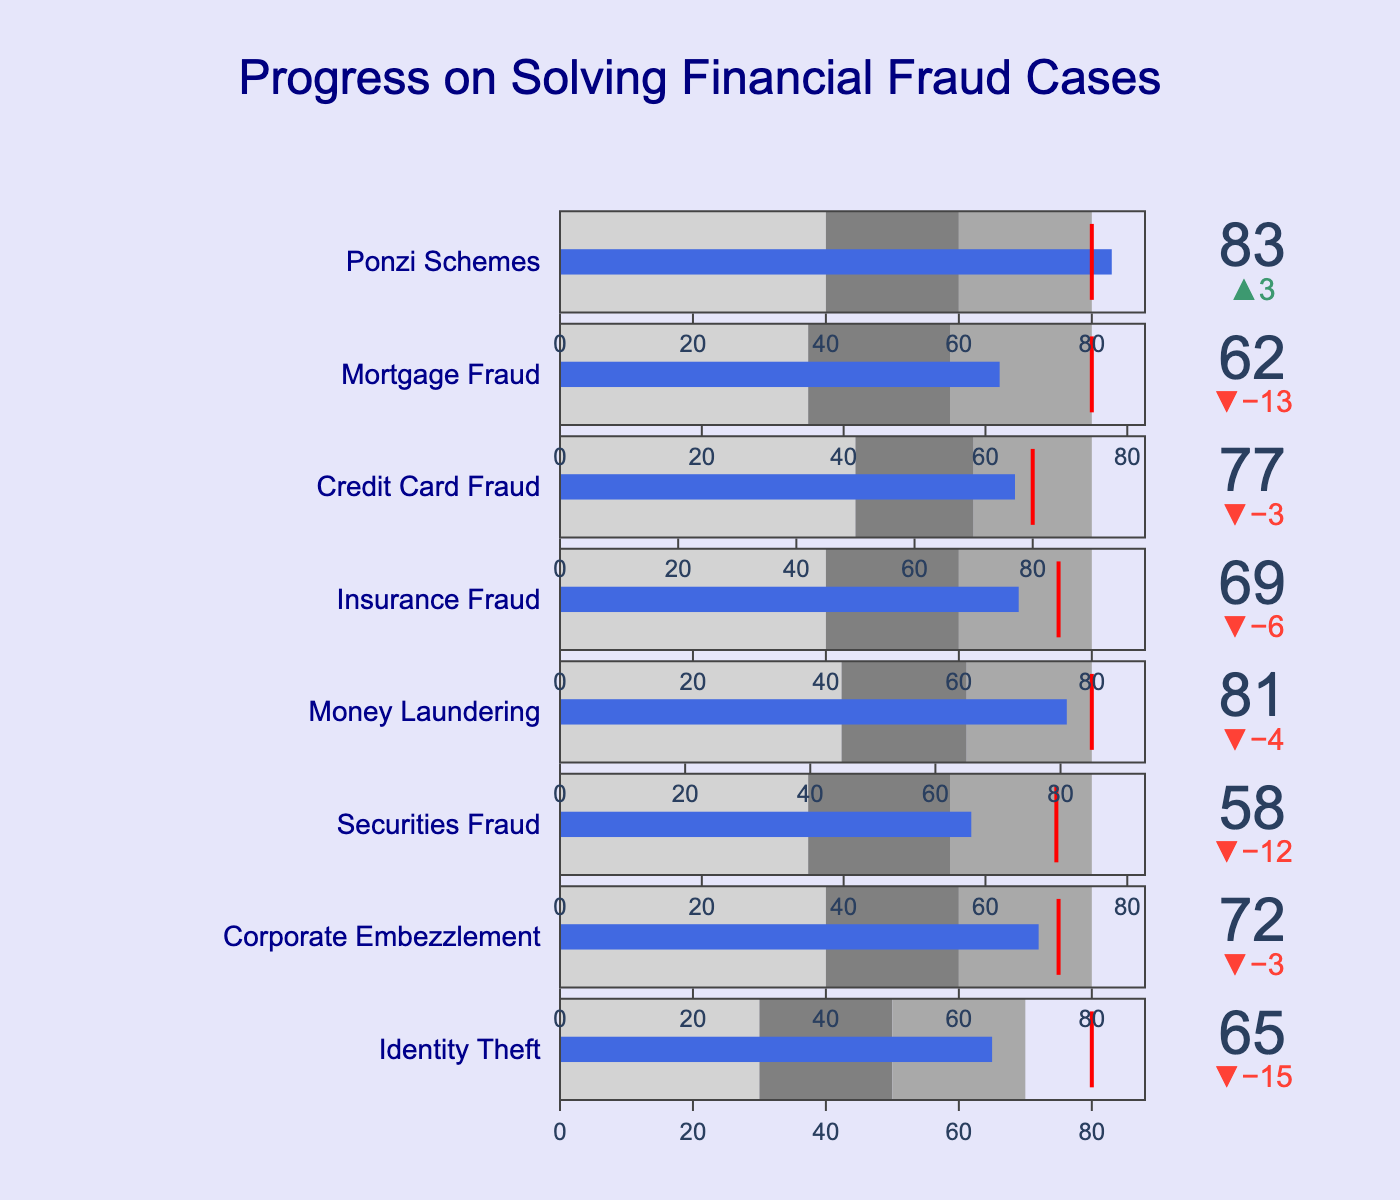What is the title of the chart? The title of the chart is prominently displayed at the top.
Answer: Progress on Solving Financial Fraud Cases What color is the bar representing the actual progress? The bar color can be seen in the context of each bullet chart.
Answer: Royal blue Which financial fraud case has the highest actual value? By examining the 'Actual' progress values, the highest value can be identified. 'Ponzi Schemes' has the highest actual value of 83.
Answer: Ponzi Schemes Did Identity Theft achieve its target? By looking at the actual value and comparing it against the target value, it can be determined if the target is achieved. The actual value (65) is less than the target value (80).
Answer: No What is the average target value for all financial fraud types? The target values for all types are added together and divided by the number of types. (80 + 75 + 70 + 85 + 75 + 80 + 75 + 80) / 8 = 620 / 8 = 77.5
Answer: 77.5 Which case has the largest deviation from the target? The delta from the target can be seen beside each progress bar. The case with the largest deviation from the target is Identity Theft with a delta of -15.
Answer: Identity Theft What is the range of actual progress values? By identifying the minimum and maximum actual progress values across all cases. The minimum is 58 (Securities Fraud) and the maximum is 83 (Ponzi Schemes).
Answer: 58 to 83 How many cases exceeded their target values? Counting the cases where the actual value is greater than the target value. Three cases (Money Laundering, Credit Card Fraud, Ponzi Schemes) have actual values above the target values.
Answer: 3 What is the color of the step indicating the middle range of progress? Observing the colors used in the gauge for the middle range (Range1 to Range2). The middle range is colored in gray.
Answer: Gray What is the combined range for Corporate Embezzlement and Mortgage Fraud? Adding the individual range of progress values for both cases. (40+60+80) for Corporate Embezzlement and (35+55+75) for Mortgage Fraud which sums up to (40+60+80)+(35+55+75)=345
Answer: 345 